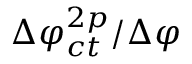<formula> <loc_0><loc_0><loc_500><loc_500>\Delta \varphi _ { c t } ^ { 2 p } / \Delta \varphi</formula> 